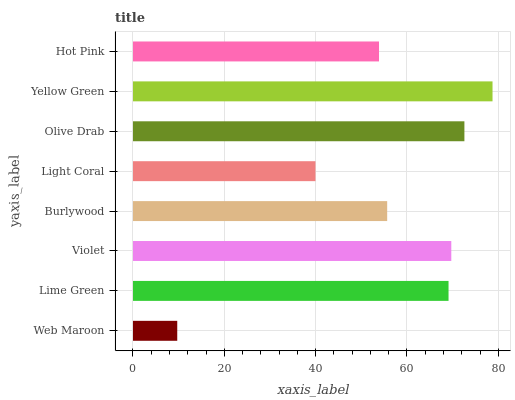Is Web Maroon the minimum?
Answer yes or no. Yes. Is Yellow Green the maximum?
Answer yes or no. Yes. Is Lime Green the minimum?
Answer yes or no. No. Is Lime Green the maximum?
Answer yes or no. No. Is Lime Green greater than Web Maroon?
Answer yes or no. Yes. Is Web Maroon less than Lime Green?
Answer yes or no. Yes. Is Web Maroon greater than Lime Green?
Answer yes or no. No. Is Lime Green less than Web Maroon?
Answer yes or no. No. Is Lime Green the high median?
Answer yes or no. Yes. Is Burlywood the low median?
Answer yes or no. Yes. Is Yellow Green the high median?
Answer yes or no. No. Is Light Coral the low median?
Answer yes or no. No. 